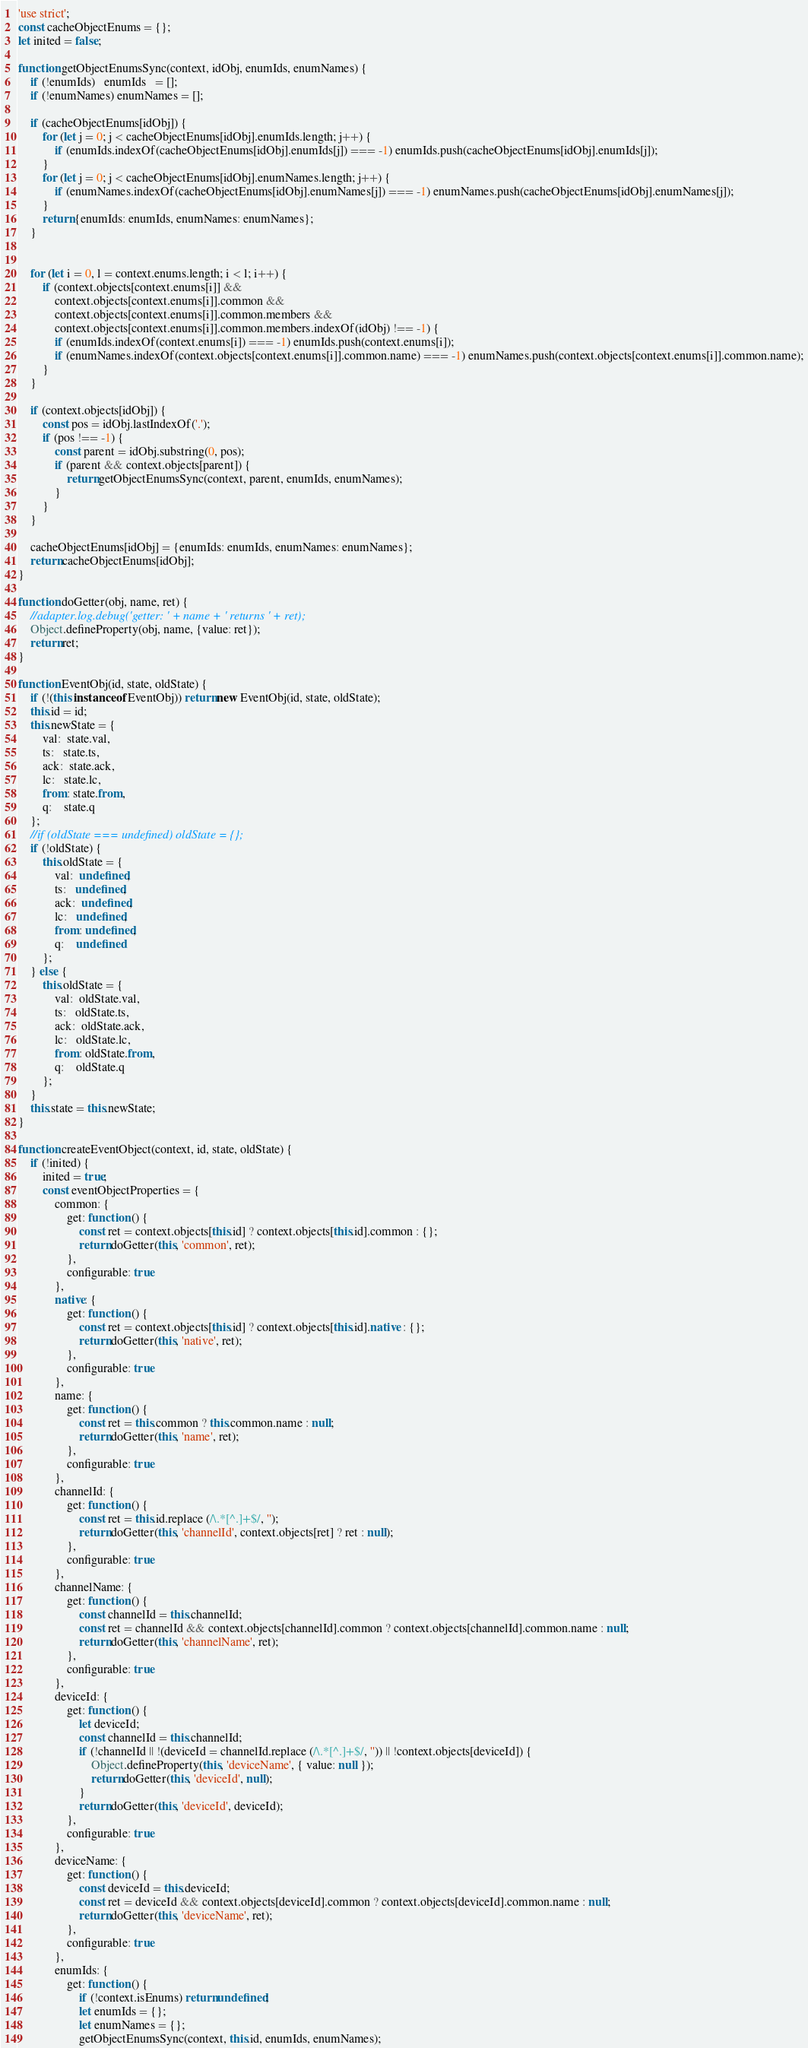<code> <loc_0><loc_0><loc_500><loc_500><_JavaScript_>'use strict';
const cacheObjectEnums = {};
let inited = false;

function getObjectEnumsSync(context, idObj, enumIds, enumNames) {
    if (!enumIds)   enumIds   = [];
    if (!enumNames) enumNames = [];

    if (cacheObjectEnums[idObj]) {
        for (let j = 0; j < cacheObjectEnums[idObj].enumIds.length; j++) {
            if (enumIds.indexOf(cacheObjectEnums[idObj].enumIds[j]) === -1) enumIds.push(cacheObjectEnums[idObj].enumIds[j]);
        }
        for (let j = 0; j < cacheObjectEnums[idObj].enumNames.length; j++) {
            if (enumNames.indexOf(cacheObjectEnums[idObj].enumNames[j]) === -1) enumNames.push(cacheObjectEnums[idObj].enumNames[j]);
        }
        return {enumIds: enumIds, enumNames: enumNames};
    }


    for (let i = 0, l = context.enums.length; i < l; i++) {
        if (context.objects[context.enums[i]] &&
            context.objects[context.enums[i]].common &&
            context.objects[context.enums[i]].common.members &&
            context.objects[context.enums[i]].common.members.indexOf(idObj) !== -1) {
            if (enumIds.indexOf(context.enums[i]) === -1) enumIds.push(context.enums[i]);
            if (enumNames.indexOf(context.objects[context.enums[i]].common.name) === -1) enumNames.push(context.objects[context.enums[i]].common.name);
        }
    }

    if (context.objects[idObj]) {
        const pos = idObj.lastIndexOf('.');
        if (pos !== -1) {
            const parent = idObj.substring(0, pos);
            if (parent && context.objects[parent]) {
                return getObjectEnumsSync(context, parent, enumIds, enumNames);
            }
        }
    }

    cacheObjectEnums[idObj] = {enumIds: enumIds, enumNames: enumNames};
    return cacheObjectEnums[idObj];
}

function doGetter(obj, name, ret) {
    //adapter.log.debug('getter: ' + name + ' returns ' + ret);
    Object.defineProperty(obj, name, {value: ret});
    return ret;
}

function EventObj(id, state, oldState) {
    if (!(this instanceof EventObj)) return new EventObj(id, state, oldState);
    this.id = id;
    this.newState = {
        val:  state.val,
        ts:   state.ts,
        ack:  state.ack,
        lc:   state.lc,
        from: state.from,
        q:    state.q
    };
    //if (oldState === undefined) oldState = {};
    if (!oldState) {
        this.oldState = {
            val:  undefined,
            ts:   undefined,
            ack:  undefined,
            lc:   undefined,
            from: undefined,
            q:    undefined
        };
    } else {
        this.oldState = {
            val:  oldState.val,
            ts:   oldState.ts,
            ack:  oldState.ack,
            lc:   oldState.lc,
            from: oldState.from,
            q:    oldState.q
        };
    }
    this.state = this.newState;
}

function createEventObject(context, id, state, oldState) {
    if (!inited) {
        inited = true;
        const eventObjectProperties = {
            common: {
                get: function () {
                    const ret = context.objects[this.id] ? context.objects[this.id].common : {};
                    return doGetter(this, 'common', ret);
                },
                configurable: true
            },
            native: {
                get: function () {
                    const ret = context.objects[this.id] ? context.objects[this.id].native : {};
                    return doGetter(this, 'native', ret);
                },
                configurable: true
            },
            name: {
                get: function () {
                    const ret = this.common ? this.common.name : null;
                    return doGetter(this, 'name', ret);
                },
                configurable: true
            },
            channelId: {
                get: function () {
                    const ret = this.id.replace (/\.*[^.]+$/, '');
                    return doGetter(this, 'channelId', context.objects[ret] ? ret : null);
                },
                configurable: true
            },
            channelName: {
                get: function () {
                    const channelId = this.channelId;
                    const ret = channelId && context.objects[channelId].common ? context.objects[channelId].common.name : null;
                    return doGetter(this, 'channelName', ret);
                },
                configurable: true
            },
            deviceId: {
                get: function () {
                    let deviceId;
                    const channelId = this.channelId;
                    if (!channelId || !(deviceId = channelId.replace (/\.*[^.]+$/, '')) || !context.objects[deviceId]) {
                        Object.defineProperty(this, 'deviceName', { value: null });
                        return doGetter(this, 'deviceId', null);
                    }
                    return doGetter(this, 'deviceId', deviceId);
                },
                configurable: true
            },
            deviceName: {
                get: function () {
                    const deviceId = this.deviceId;
                    const ret = deviceId && context.objects[deviceId].common ? context.objects[deviceId].common.name : null;
                    return doGetter(this, 'deviceName', ret);
                },
                configurable: true
            },
            enumIds: {
                get: function () {
                    if (!context.isEnums) return undefined;
                    let enumIds = {};
                    let enumNames = {};
                    getObjectEnumsSync(context, this.id, enumIds, enumNames);</code> 